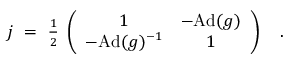Convert formula to latex. <formula><loc_0><loc_0><loc_500><loc_500>j = { \frac { 1 } { 2 } } \, \left ( \begin{array} { c c } { 1 } & { - A d ( g ) } \\ { { - A d ( g ) ^ { - 1 } } } & { 1 } \end{array} \right ) .</formula> 